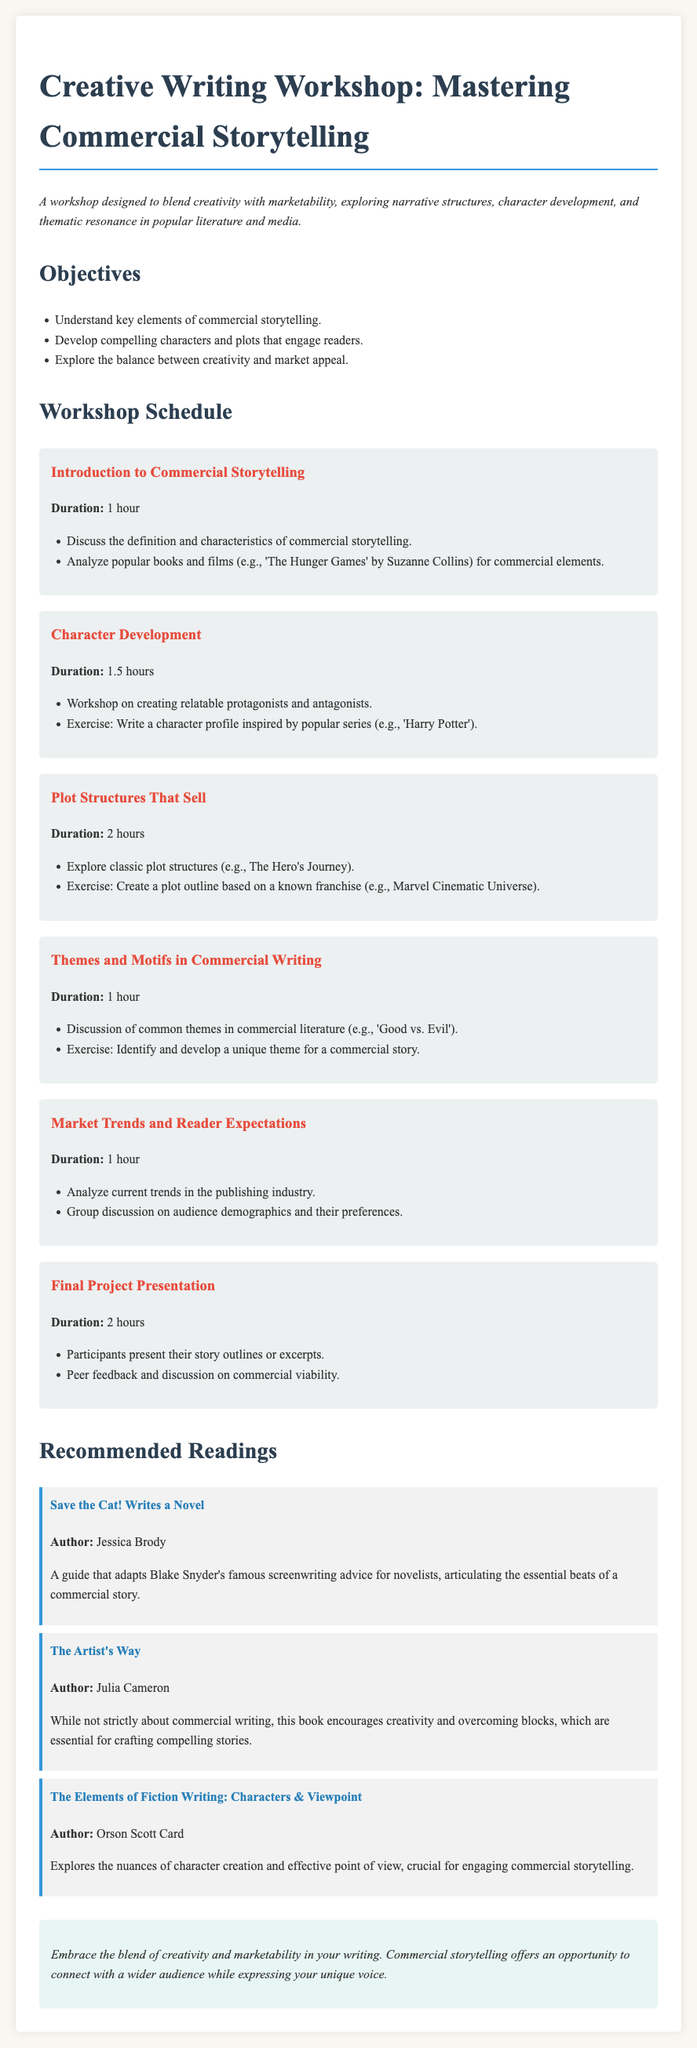What is the title of the workshop? The title is prominently displayed at the beginning of the document, which is "Creative Writing Workshop: Mastering Commercial Storytelling."
Answer: Creative Writing Workshop: Mastering Commercial Storytelling How many hours is the "Character Development" session? The duration for the "Character Development" session is specified in the document.
Answer: 1.5 hours Who is the author of "Save the Cat! Writes a Novel"? The author is listed in the recommended readings section of the document.
Answer: Jessica Brody What is one common theme discussed in the workshop? The document mentions a specific theme in commercial literature during the session on themes and motifs.
Answer: Good vs. Evil What is the duration of the "Final Project Presentation"? The duration is stated under the final project session in the workshop schedule.
Answer: 2 hours What exercise is included in the "Plot Structures That Sell" session? The exercise is detailed in the session description related to plot structures.
Answer: Create a plot outline based on a known franchise How many objectives are listed in the workshop? The total number of objectives is provided in the objectives section.
Answer: 3 What style of font is used for the document's body text? The document specifies the font used for body text in the CSS styling section.
Answer: Libre Baskerville What type of writing does "The Artist's Way" promote? The document describes the intent of "The Artist's Way" in the context of commercial writing frameworks.
Answer: Creativity and overcoming blocks 